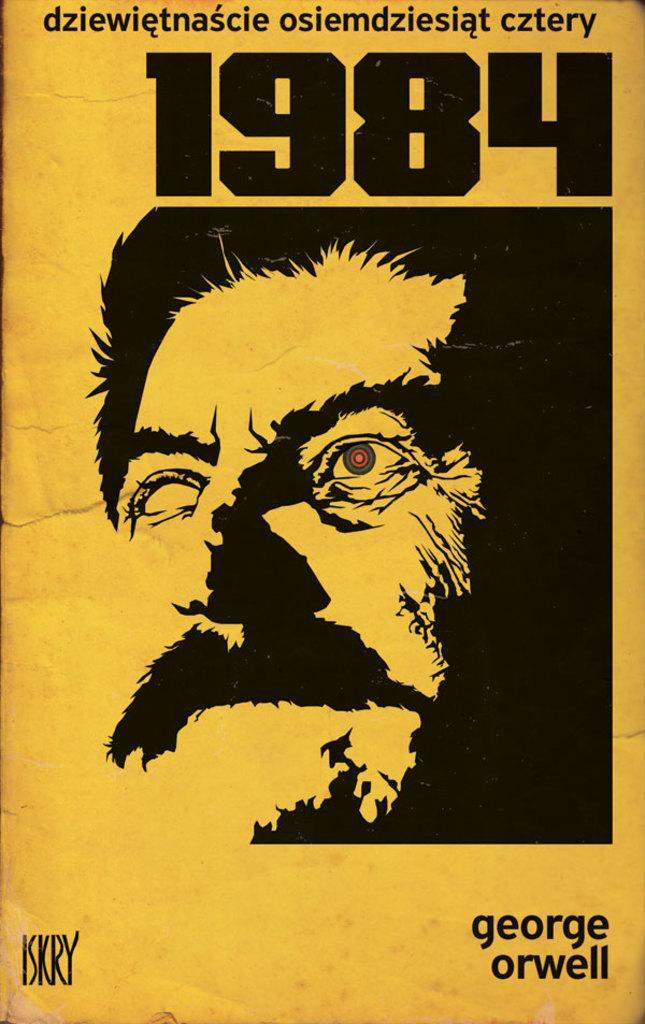What is the main subject of the image? There is a person's face in the image. What is unique about the person's face in the image? There is text written on the person's face. What color is the background of the image? The background color is yellow. Can you tell me how many robins are perched on the person's tongue in the image? There are no robins present in the image, and the person's tongue is not visible. 